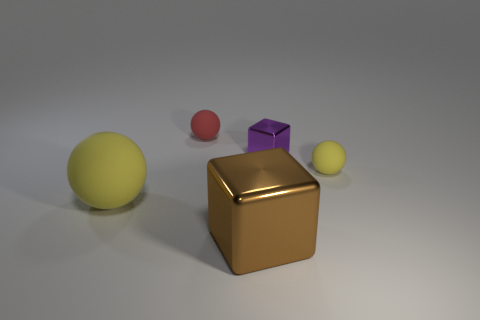There is a object that is to the left of the big metal block and on the right side of the large sphere; what material is it?
Offer a terse response. Rubber. There is a ball that is the same size as the brown thing; what color is it?
Your answer should be compact. Yellow. Is the material of the tiny cube the same as the tiny ball that is on the left side of the big brown metallic object?
Provide a short and direct response. No. What number of other things are the same size as the purple shiny object?
Provide a short and direct response. 2. There is a tiny ball behind the matte object that is right of the brown shiny cube; is there a small purple cube behind it?
Your answer should be very brief. No. What size is the red rubber ball?
Make the answer very short. Small. What size is the yellow ball on the left side of the brown metal object?
Provide a succinct answer. Large. There is a matte ball that is on the right side of the purple metal block; is its size the same as the red matte sphere?
Offer a terse response. Yes. Is there any other thing that has the same color as the tiny metallic object?
Keep it short and to the point. No. The small yellow object has what shape?
Ensure brevity in your answer.  Sphere. 